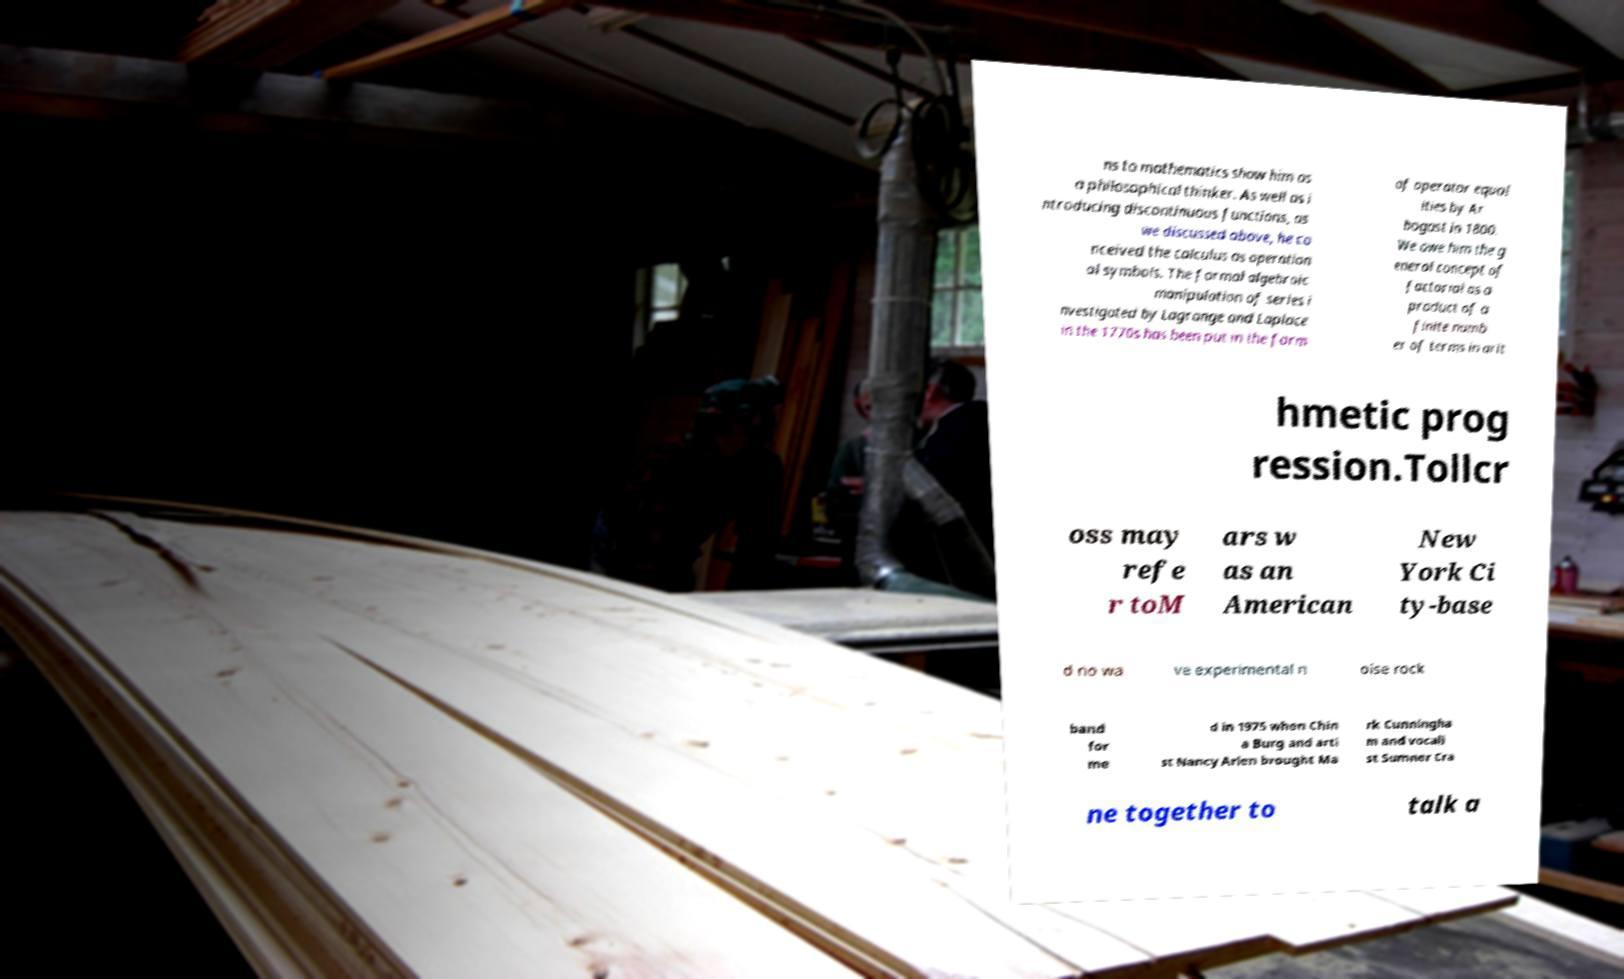Can you accurately transcribe the text from the provided image for me? ns to mathematics show him as a philosophical thinker. As well as i ntroducing discontinuous functions, as we discussed above, he co nceived the calculus as operation al symbols. The formal algebraic manipulation of series i nvestigated by Lagrange and Laplace in the 1770s has been put in the form of operator equal ities by Ar bogast in 1800. We owe him the g eneral concept of factorial as a product of a finite numb er of terms in arit hmetic prog ression.Tollcr oss may refe r toM ars w as an American New York Ci ty-base d no wa ve experimental n oise rock band for me d in 1975 when Chin a Burg and arti st Nancy Arlen brought Ma rk Cunningha m and vocali st Sumner Cra ne together to talk a 